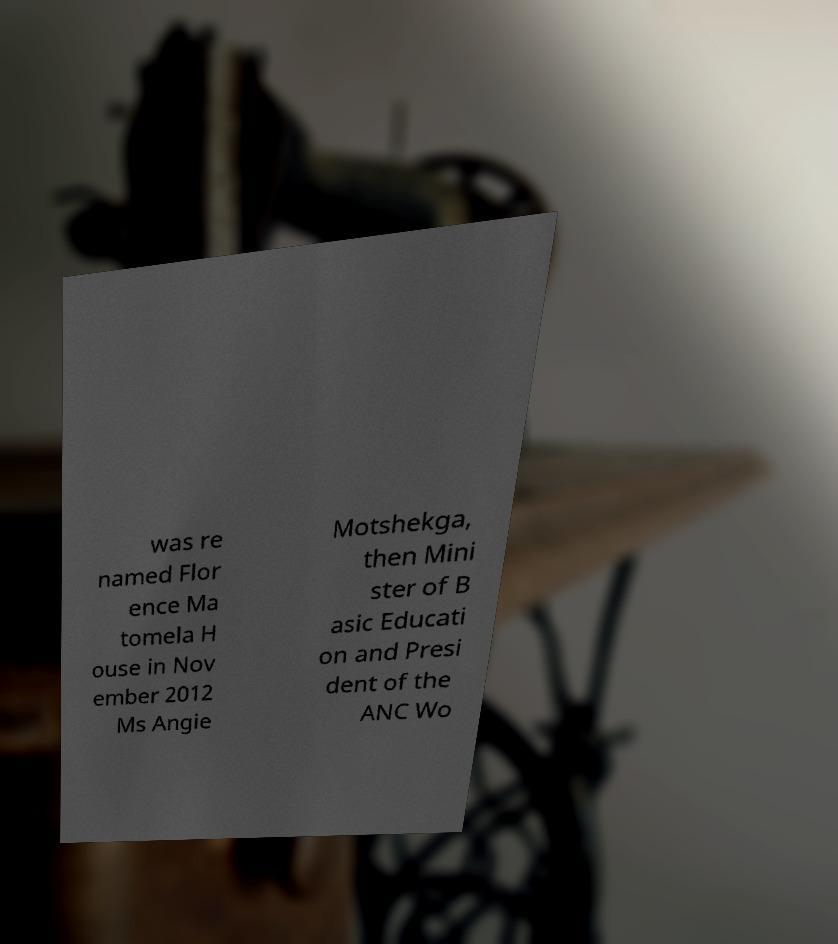Please identify and transcribe the text found in this image. was re named Flor ence Ma tomela H ouse in Nov ember 2012 Ms Angie Motshekga, then Mini ster of B asic Educati on and Presi dent of the ANC Wo 